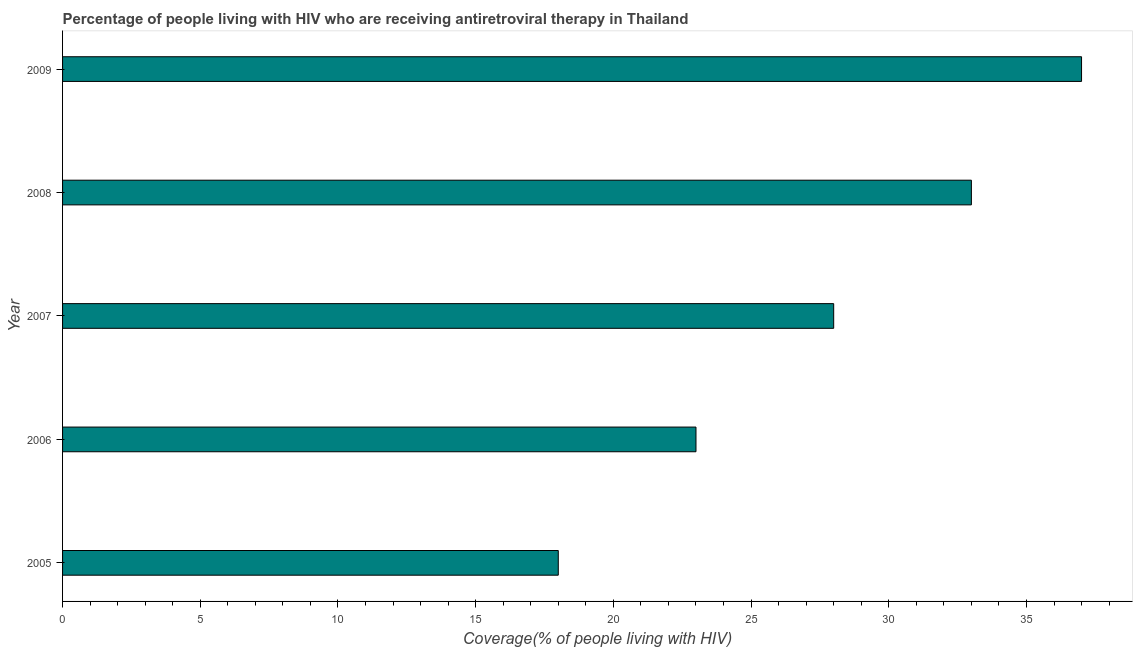Does the graph contain any zero values?
Your answer should be compact. No. What is the title of the graph?
Ensure brevity in your answer.  Percentage of people living with HIV who are receiving antiretroviral therapy in Thailand. What is the label or title of the X-axis?
Offer a terse response. Coverage(% of people living with HIV). What is the sum of the antiretroviral therapy coverage?
Your answer should be very brief. 139. What is the difference between the antiretroviral therapy coverage in 2006 and 2007?
Keep it short and to the point. -5. What is the ratio of the antiretroviral therapy coverage in 2007 to that in 2008?
Keep it short and to the point. 0.85. Is the difference between the antiretroviral therapy coverage in 2005 and 2006 greater than the difference between any two years?
Give a very brief answer. No. In how many years, is the antiretroviral therapy coverage greater than the average antiretroviral therapy coverage taken over all years?
Ensure brevity in your answer.  3. How many years are there in the graph?
Give a very brief answer. 5. What is the difference between two consecutive major ticks on the X-axis?
Provide a succinct answer. 5. What is the Coverage(% of people living with HIV) in 2005?
Offer a very short reply. 18. What is the Coverage(% of people living with HIV) of 2008?
Give a very brief answer. 33. What is the difference between the Coverage(% of people living with HIV) in 2005 and 2006?
Make the answer very short. -5. What is the difference between the Coverage(% of people living with HIV) in 2006 and 2007?
Make the answer very short. -5. What is the difference between the Coverage(% of people living with HIV) in 2006 and 2008?
Keep it short and to the point. -10. What is the difference between the Coverage(% of people living with HIV) in 2007 and 2008?
Make the answer very short. -5. What is the ratio of the Coverage(% of people living with HIV) in 2005 to that in 2006?
Provide a succinct answer. 0.78. What is the ratio of the Coverage(% of people living with HIV) in 2005 to that in 2007?
Keep it short and to the point. 0.64. What is the ratio of the Coverage(% of people living with HIV) in 2005 to that in 2008?
Your answer should be very brief. 0.55. What is the ratio of the Coverage(% of people living with HIV) in 2005 to that in 2009?
Offer a very short reply. 0.49. What is the ratio of the Coverage(% of people living with HIV) in 2006 to that in 2007?
Provide a succinct answer. 0.82. What is the ratio of the Coverage(% of people living with HIV) in 2006 to that in 2008?
Offer a very short reply. 0.7. What is the ratio of the Coverage(% of people living with HIV) in 2006 to that in 2009?
Ensure brevity in your answer.  0.62. What is the ratio of the Coverage(% of people living with HIV) in 2007 to that in 2008?
Provide a succinct answer. 0.85. What is the ratio of the Coverage(% of people living with HIV) in 2007 to that in 2009?
Make the answer very short. 0.76. What is the ratio of the Coverage(% of people living with HIV) in 2008 to that in 2009?
Ensure brevity in your answer.  0.89. 